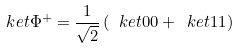<formula> <loc_0><loc_0><loc_500><loc_500>\ k e t { \Phi ^ { + } } = \frac { 1 } { \sqrt { 2 } } \left ( \ k e t { 0 0 } + \ k e t { 1 1 } \right )</formula> 